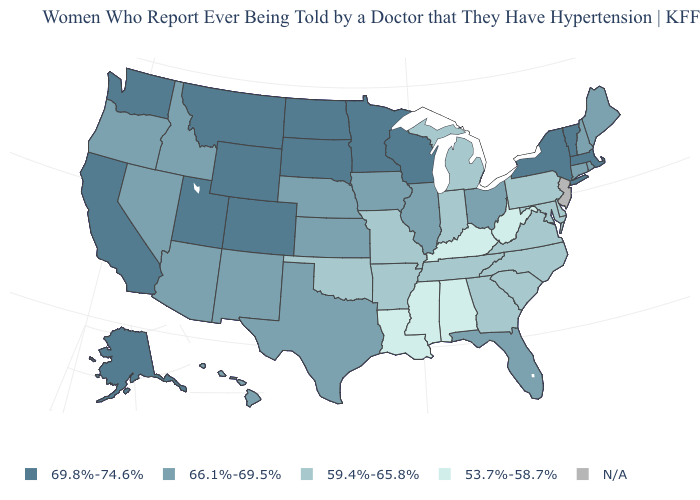Among the states that border Pennsylvania , which have the lowest value?
Quick response, please. West Virginia. Name the states that have a value in the range 66.1%-69.5%?
Give a very brief answer. Arizona, Connecticut, Florida, Hawaii, Idaho, Illinois, Iowa, Kansas, Maine, Nebraska, Nevada, New Hampshire, New Mexico, Ohio, Oregon, Rhode Island, Texas. Which states hav the highest value in the MidWest?
Concise answer only. Minnesota, North Dakota, South Dakota, Wisconsin. What is the value of Kansas?
Short answer required. 66.1%-69.5%. Which states have the lowest value in the USA?
Concise answer only. Alabama, Kentucky, Louisiana, Mississippi, West Virginia. What is the value of Rhode Island?
Quick response, please. 66.1%-69.5%. Does North Carolina have the highest value in the USA?
Concise answer only. No. Is the legend a continuous bar?
Write a very short answer. No. Among the states that border California , which have the lowest value?
Keep it brief. Arizona, Nevada, Oregon. Name the states that have a value in the range 53.7%-58.7%?
Concise answer only. Alabama, Kentucky, Louisiana, Mississippi, West Virginia. Does Oklahoma have the highest value in the USA?
Quick response, please. No. What is the highest value in the USA?
Answer briefly. 69.8%-74.6%. 